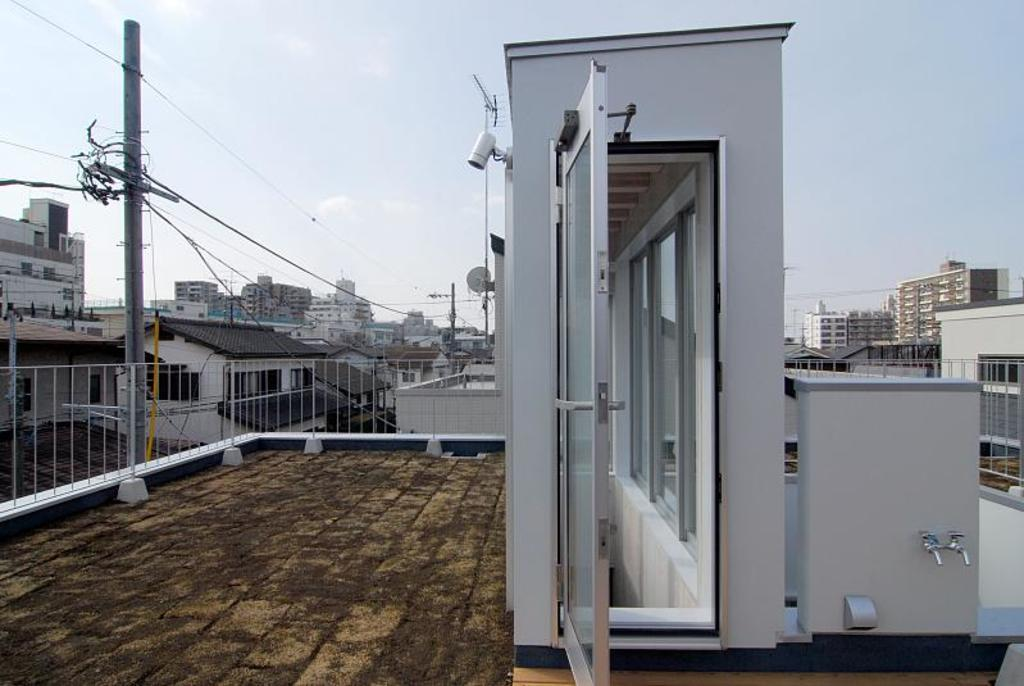What type of structures can be seen in the image? There are electric poles and buildings in the image. What colors are the buildings? The buildings are in white, brown, and cream colors. What part of the buildings is visible in the image? The railing is visible in the image. What is the color of the sky in the background? The sky in the background is white. Can you see any ghosts interacting with the electric poles in the image? There are no ghosts present in the image; it only features electric poles and buildings. Is there a baby crawling on the railing in the image? There is no baby present in the image; it only features electric poles, buildings, and a railing. 